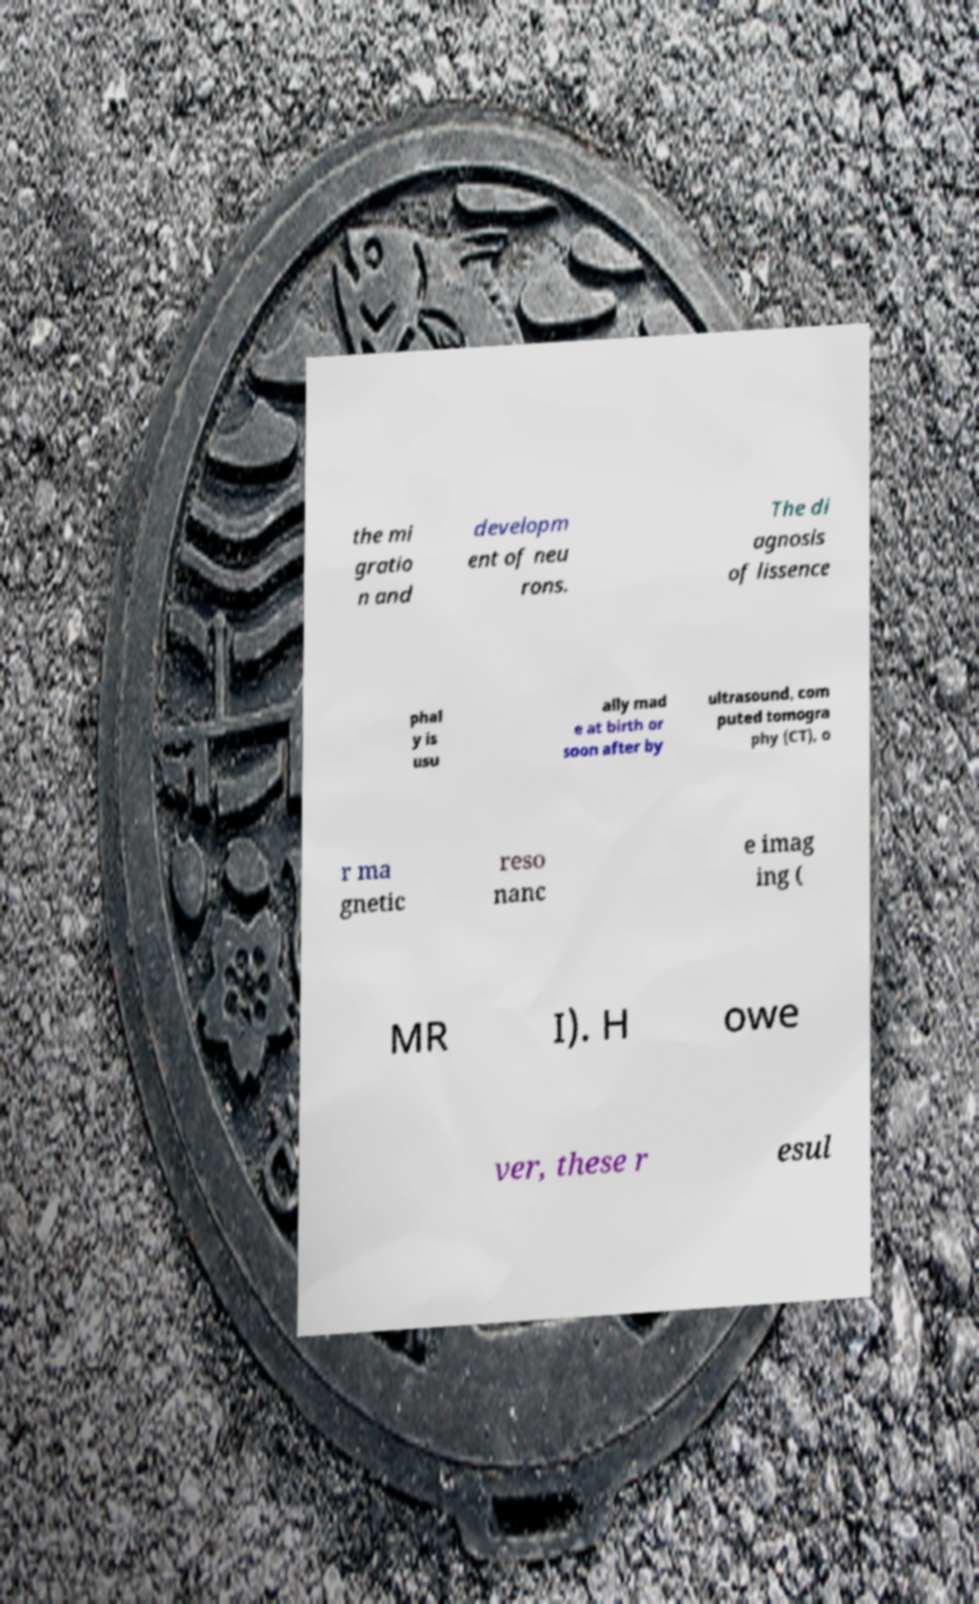For documentation purposes, I need the text within this image transcribed. Could you provide that? the mi gratio n and developm ent of neu rons. The di agnosis of lissence phal y is usu ally mad e at birth or soon after by ultrasound, com puted tomogra phy (CT), o r ma gnetic reso nanc e imag ing ( MR I). H owe ver, these r esul 